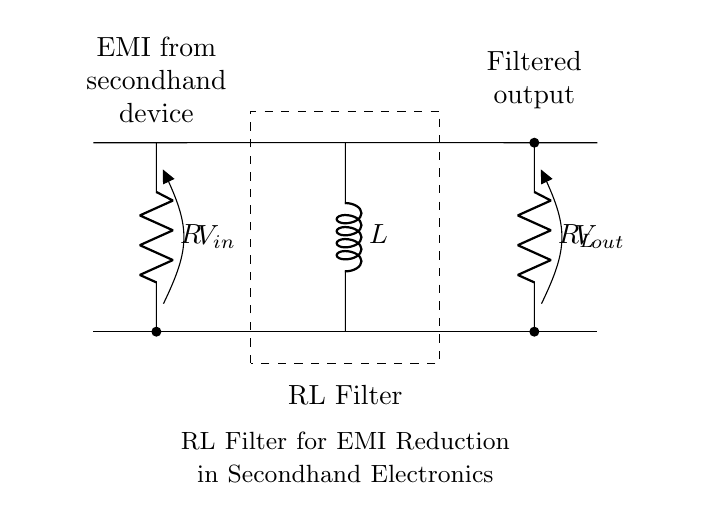What is the type of this filter circuit? This circuit is an RL filter, as it consists of a resistor and an inductor. The presence of both these components indicates that it functions to filter signals, specifically to reduce electromagnetic interference.
Answer: RL filter What does "V in" represent? "V in" represents the input voltage applied to the circuit. It is the voltage received from the secondhand device that may contain electromagnetic interference.
Answer: Input voltage What is the purpose of the inductor in this circuit? The inductor's role is to oppose changes in current flow, which helps in filtering out high-frequency noise and electromagnetic interference present in the input signal. This results in a smoother output signal.
Answer: Filter EMI How many resistors are present in this circuit? There are two resistors in the circuit: one is labeled "R" and the other is labeled "R L." They help in dissipating energy and determining the overall resistance of the circuit.
Answer: Two What is the output of this RL filter? The output of the RL filter is the voltage across "R L," which represents the filtered signal after the input interference has been reduced. The filtered output voltage reflects a cleaner signal.
Answer: Filtered output What happens to the current through the inductor when the input voltage changes suddenly? When the input voltage changes suddenly, the inductor resists the sudden change in current due to its property of inductance. This causes the current through the inductor to increase or decrease gradually rather than instantly, which helps in smoothing the output.
Answer: Gradual change What is the function of the dashed rectangle in the circuit diagram? The dashed rectangle indicates the space or area specifically designated for the RL filter circuit. It helps to visually identify the components that are part of the filtering process and emphasizes the unitary function of the connected parts.
Answer: Indicates filtering area 